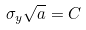Convert formula to latex. <formula><loc_0><loc_0><loc_500><loc_500>\sigma _ { y } \sqrt { a } = C</formula> 